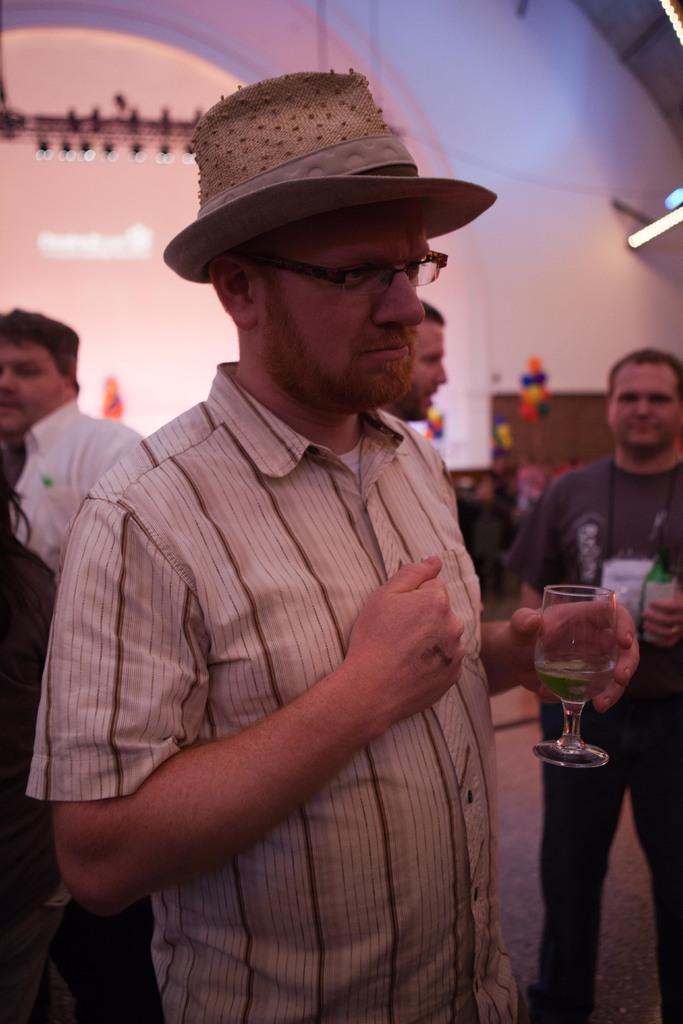How would you summarize this image in a sentence or two? It´s a closed room where four people are present, one man is standing and holding a glass in hand and wearing a cap and he is wearing glasses too, beside him at the right corner of the picture there is one person wearing black t-shirt and holding a glass, behind him there is a wall and a light. 